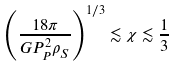<formula> <loc_0><loc_0><loc_500><loc_500>\left ( \frac { 1 8 \pi } { G P _ { P } ^ { 2 } \rho _ { S } } \right ) ^ { 1 / 3 } \lesssim \chi \lesssim \frac { 1 } { 3 }</formula> 